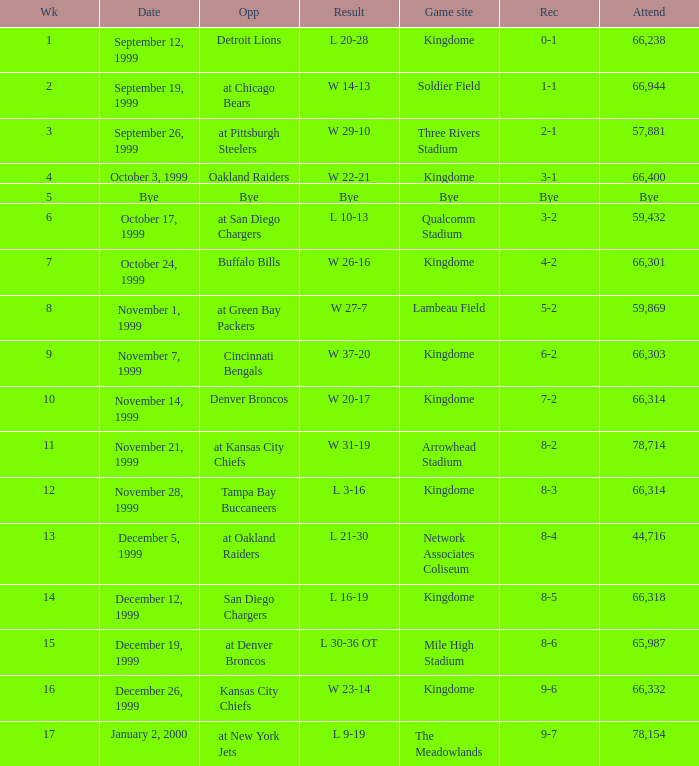For the game that was played on week 2, what is the record? 1-1. 